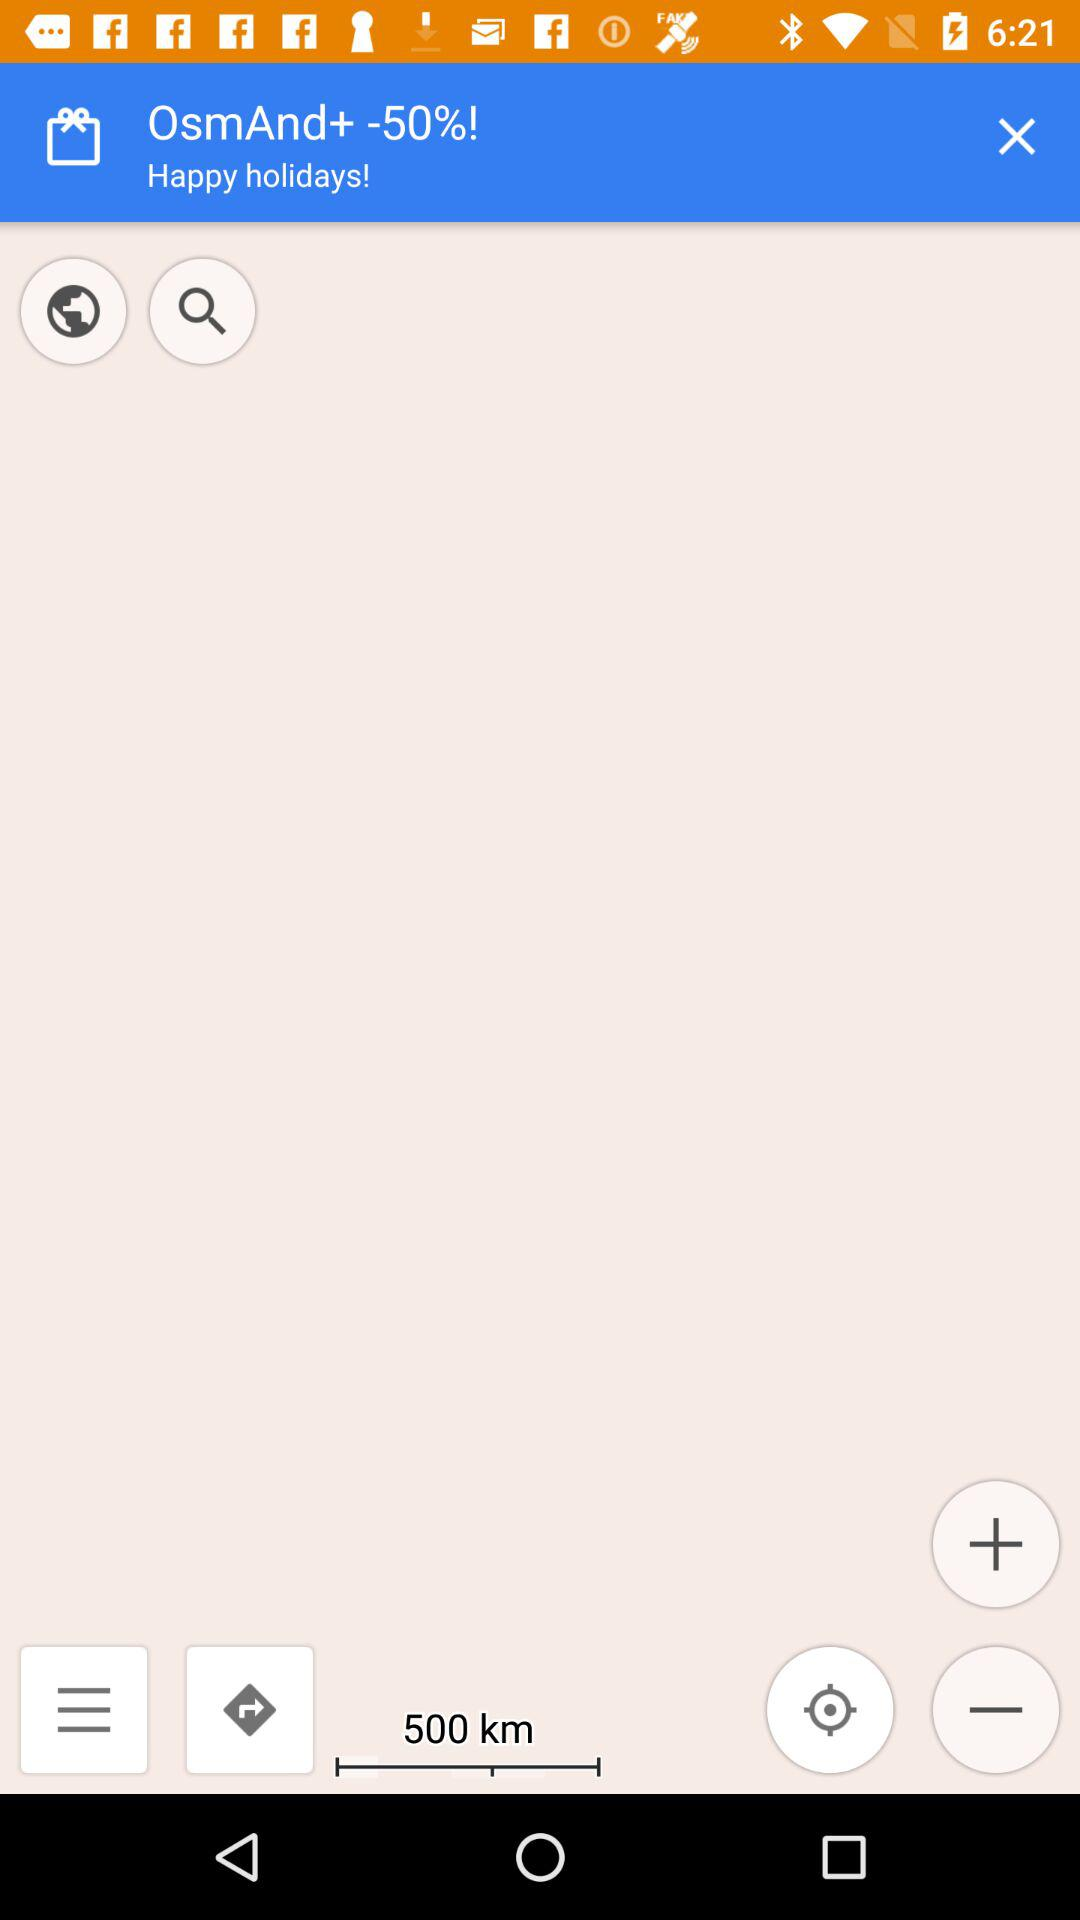How much is the discount on OsmAnd+?
Answer the question using a single word or phrase. -50% 